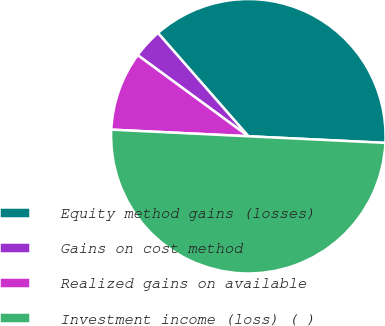Convert chart to OTSL. <chart><loc_0><loc_0><loc_500><loc_500><pie_chart><fcel>Equity method gains (losses)<fcel>Gains on cost method<fcel>Realized gains on available<fcel>Investment income (loss) ( )<nl><fcel>37.21%<fcel>3.49%<fcel>9.3%<fcel>50.0%<nl></chart> 